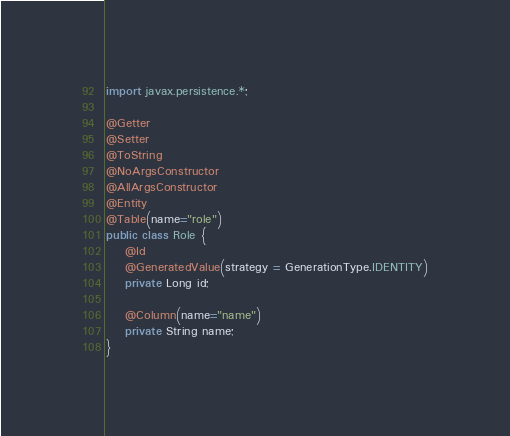Convert code to text. <code><loc_0><loc_0><loc_500><loc_500><_Java_>import javax.persistence.*;

@Getter
@Setter
@ToString
@NoArgsConstructor
@AllArgsConstructor
@Entity
@Table(name="role")
public class Role {
    @Id
    @GeneratedValue(strategy = GenerationType.IDENTITY)
    private Long id;

    @Column(name="name")
    private String name;
}
</code> 